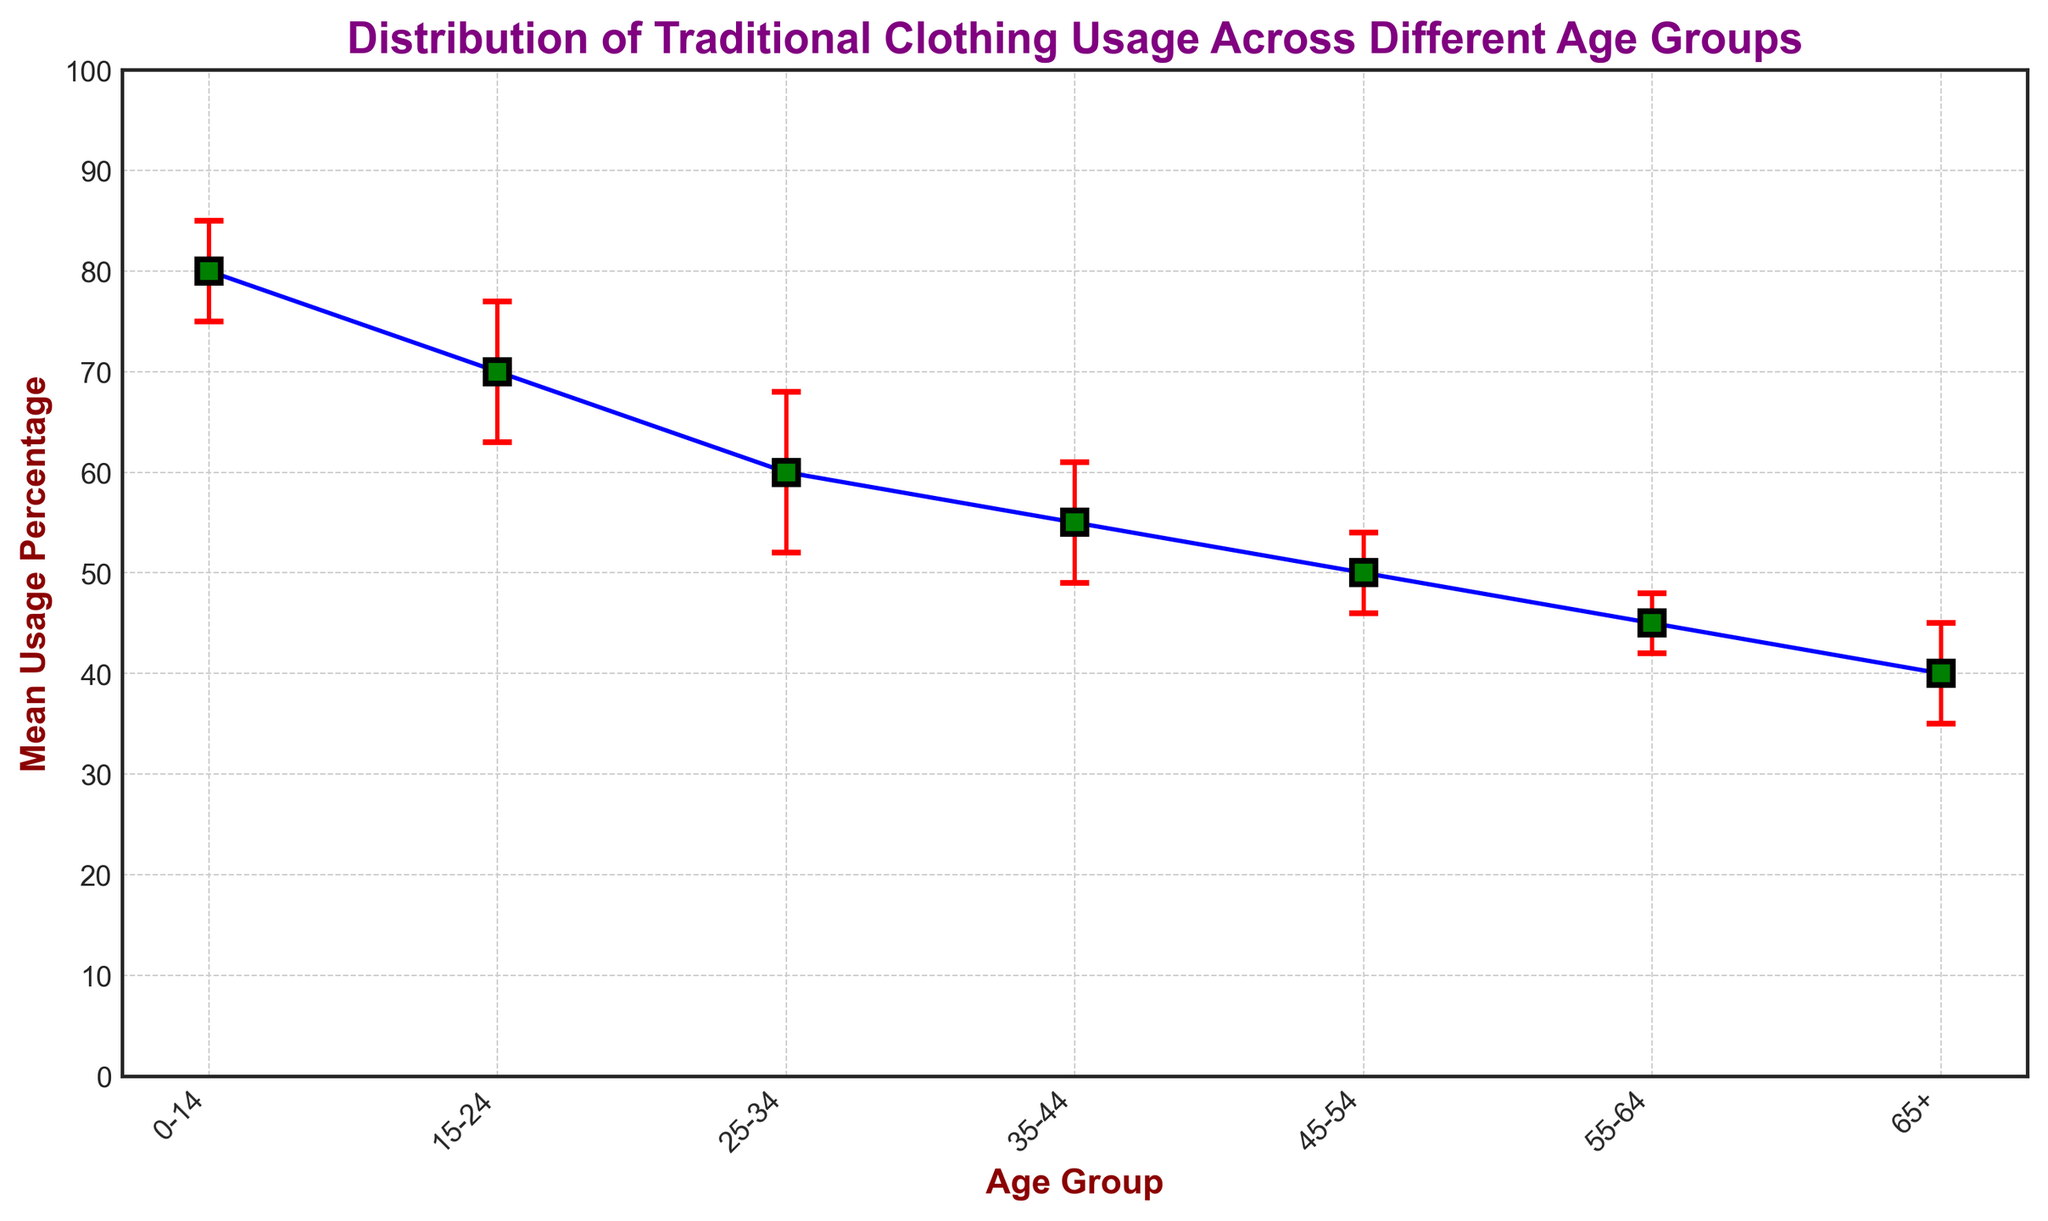What is the age group with the highest mean usage percentage of traditional clothing? To find the age group with the highest mean usage percentage, look for the topmost data point on the plot. The 0-14 age group has a mean usage percentage of 80, which is the highest.
Answer: 0-14 Which age group has the lowest mean usage percentage of traditional clothing? Locate the data point with the lowest vertical position on the plot. The 65+ age group has the lowest mean usage percentage of 40.
Answer: 65+ What is the difference in mean usage percentage between the 15-24 age group and the 55-64 age group? Subtract the mean usage percentage of the 55-64 age group (45) from the 15-24 age group (70). The difference is 70 - 45 = 25.
Answer: 25 Which age group has the largest standard deviation in traditional clothing usage? Identify the data point with the longest error bar, indicating the largest standard deviation. The 25-34 age group has the largest standard deviation of 8.
Answer: 25-34 What is the mean usage percentage and standard deviation for the 35-44 age group? Look at the data point for the 35-44 age group. The mean usage percentage is 55 and the standard deviation is 6.
Answer: 55, 6 Among the age groups 25-34 and 45-54, which has a higher mean usage percentage and by how much? Compare the mean usage percentages of these two groups. The 25-34 age group has a mean of 60, while the 45-54 age group has a mean of 50. The difference is 60 - 50 = 10.
Answer: 25-34, 10 What is the sum of the mean usage percentages for the 0-14 and 65+ age groups? Add the mean usage percentages of these two age groups. The sum is 80 (for 0-14) + 40 (for 65+) = 120.
Answer: 120 Which age group shows a higher variation in usage, the 15-24 or the 45-54 age group? Compare the standard deviations of these two age groups. The 15-24 age group has a standard deviation of 7, while the 45-54 age group has a standard deviation of 4. Therefore, the 15-24 age group shows higher variation.
Answer: 15-24 What is the range of mean usage percentages across all age groups? Subtract the lowest mean usage percentage (40 for 65+) from the highest mean usage percentage (80 for 0-14). The range is 80 - 40 = 40.
Answer: 40 